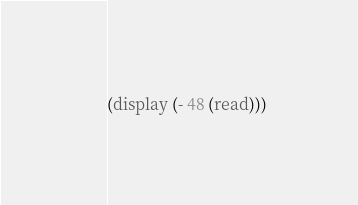<code> <loc_0><loc_0><loc_500><loc_500><_Scheme_>(display (- 48 (read)))</code> 